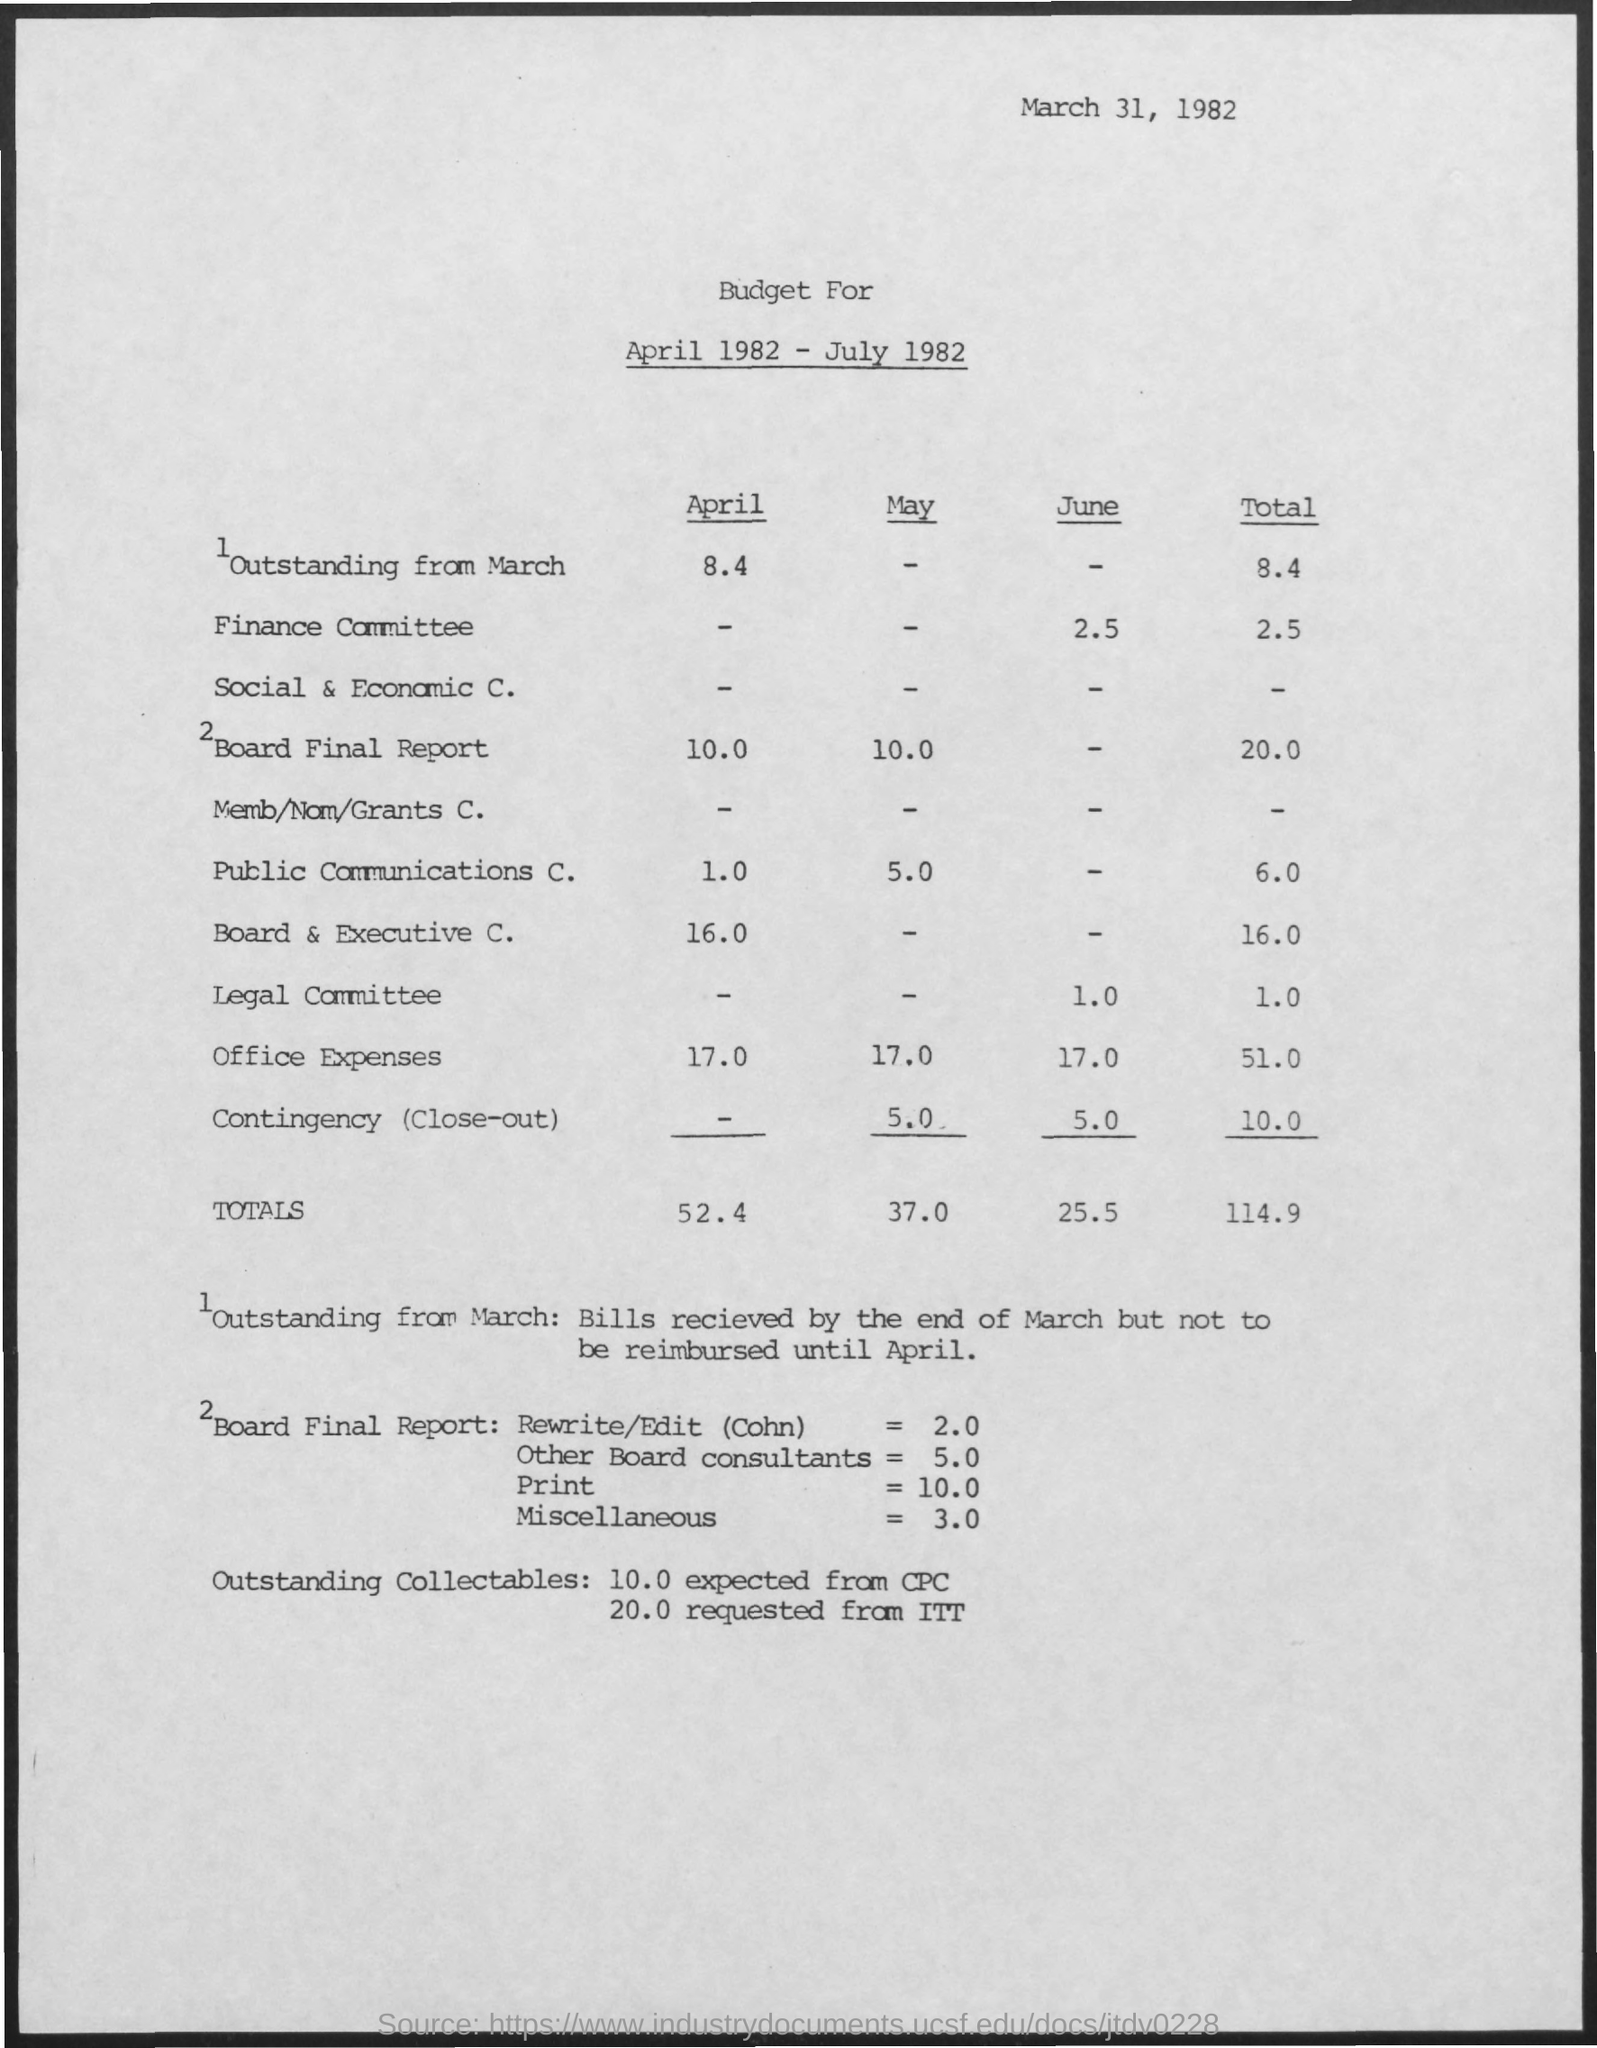What is the date on the document?
Make the answer very short. March 31, 1982. What is the Budget for Outstanding from March in April?
Offer a terse response. 8.4. What is the Budget for Outstanding from March Total?
Offer a terse response. 8.4. What is the Budget for Finance Committee in June?
Offer a very short reply. 2.5. What is the Budget for Finance Committee Total?
Your response must be concise. 2.5. What is the Budget for Board Final Report in April?
Make the answer very short. 10.0. What is the Budget for Board Final Report in May?
Keep it short and to the point. 10.0. What is the Budget for Board Final Report Total?
Make the answer very short. 20.0. What are the Totals for April?
Give a very brief answer. 52.4. What are the Totals for May?
Make the answer very short. 37.0. What are the Totals for June?
Ensure brevity in your answer.  25.5. 